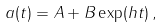Convert formula to latex. <formula><loc_0><loc_0><loc_500><loc_500>a ( t ) = A + B \exp ( h t ) \, ,</formula> 